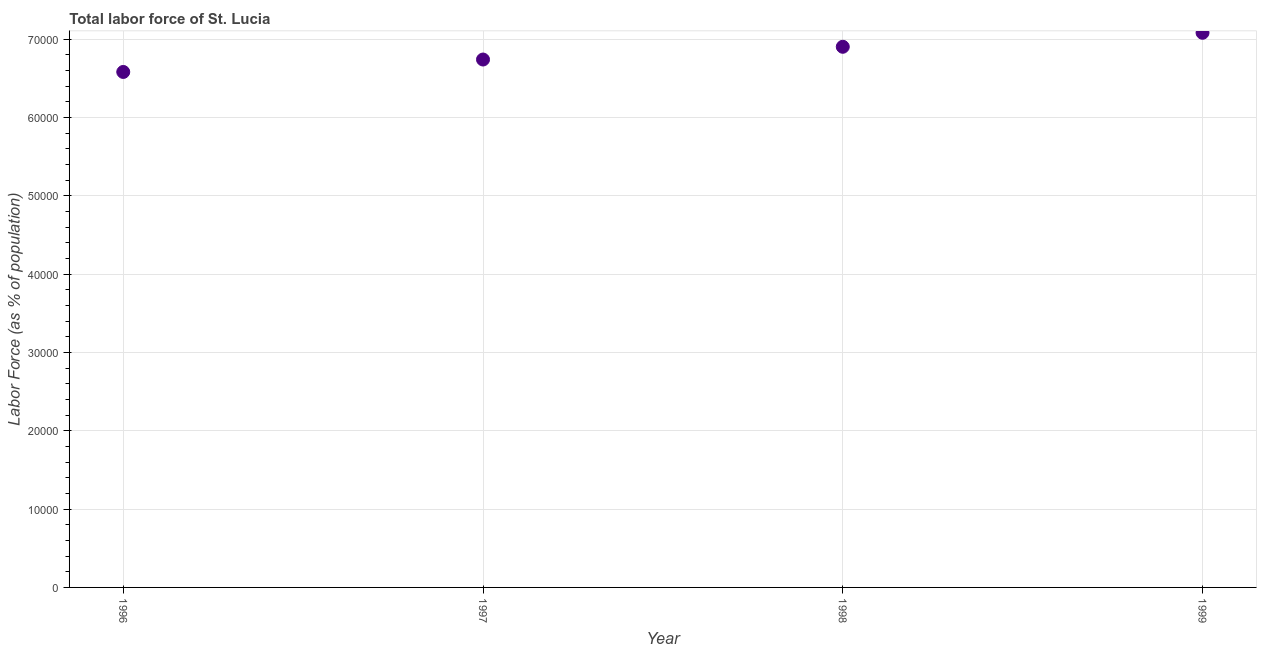What is the total labor force in 1998?
Ensure brevity in your answer.  6.90e+04. Across all years, what is the maximum total labor force?
Make the answer very short. 7.08e+04. Across all years, what is the minimum total labor force?
Provide a succinct answer. 6.58e+04. In which year was the total labor force maximum?
Your answer should be compact. 1999. In which year was the total labor force minimum?
Keep it short and to the point. 1996. What is the sum of the total labor force?
Provide a succinct answer. 2.73e+05. What is the difference between the total labor force in 1998 and 1999?
Ensure brevity in your answer.  -1788. What is the average total labor force per year?
Your answer should be very brief. 6.83e+04. What is the median total labor force?
Provide a short and direct response. 6.82e+04. What is the ratio of the total labor force in 1998 to that in 1999?
Your answer should be very brief. 0.97. What is the difference between the highest and the second highest total labor force?
Give a very brief answer. 1788. What is the difference between the highest and the lowest total labor force?
Your response must be concise. 5003. In how many years, is the total labor force greater than the average total labor force taken over all years?
Your answer should be compact. 2. Does the total labor force monotonically increase over the years?
Provide a short and direct response. Yes. How many dotlines are there?
Your response must be concise. 1. How many years are there in the graph?
Ensure brevity in your answer.  4. What is the title of the graph?
Offer a very short reply. Total labor force of St. Lucia. What is the label or title of the X-axis?
Your answer should be very brief. Year. What is the label or title of the Y-axis?
Ensure brevity in your answer.  Labor Force (as % of population). What is the Labor Force (as % of population) in 1996?
Offer a terse response. 6.58e+04. What is the Labor Force (as % of population) in 1997?
Keep it short and to the point. 6.74e+04. What is the Labor Force (as % of population) in 1998?
Your answer should be compact. 6.90e+04. What is the Labor Force (as % of population) in 1999?
Provide a short and direct response. 7.08e+04. What is the difference between the Labor Force (as % of population) in 1996 and 1997?
Your response must be concise. -1587. What is the difference between the Labor Force (as % of population) in 1996 and 1998?
Offer a terse response. -3215. What is the difference between the Labor Force (as % of population) in 1996 and 1999?
Keep it short and to the point. -5003. What is the difference between the Labor Force (as % of population) in 1997 and 1998?
Provide a short and direct response. -1628. What is the difference between the Labor Force (as % of population) in 1997 and 1999?
Provide a succinct answer. -3416. What is the difference between the Labor Force (as % of population) in 1998 and 1999?
Your response must be concise. -1788. What is the ratio of the Labor Force (as % of population) in 1996 to that in 1997?
Ensure brevity in your answer.  0.98. What is the ratio of the Labor Force (as % of population) in 1996 to that in 1998?
Offer a terse response. 0.95. What is the ratio of the Labor Force (as % of population) in 1996 to that in 1999?
Keep it short and to the point. 0.93. What is the ratio of the Labor Force (as % of population) in 1997 to that in 1998?
Offer a terse response. 0.98. What is the ratio of the Labor Force (as % of population) in 1998 to that in 1999?
Make the answer very short. 0.97. 